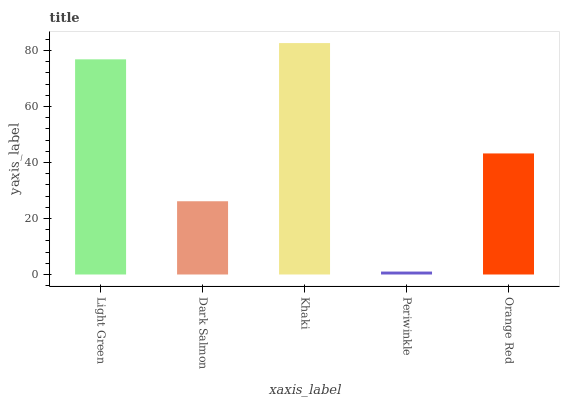Is Periwinkle the minimum?
Answer yes or no. Yes. Is Khaki the maximum?
Answer yes or no. Yes. Is Dark Salmon the minimum?
Answer yes or no. No. Is Dark Salmon the maximum?
Answer yes or no. No. Is Light Green greater than Dark Salmon?
Answer yes or no. Yes. Is Dark Salmon less than Light Green?
Answer yes or no. Yes. Is Dark Salmon greater than Light Green?
Answer yes or no. No. Is Light Green less than Dark Salmon?
Answer yes or no. No. Is Orange Red the high median?
Answer yes or no. Yes. Is Orange Red the low median?
Answer yes or no. Yes. Is Light Green the high median?
Answer yes or no. No. Is Periwinkle the low median?
Answer yes or no. No. 